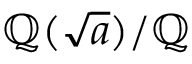<formula> <loc_0><loc_0><loc_500><loc_500>\mathbb { Q } ( { \sqrt { a } } ) / \mathbb { Q }</formula> 